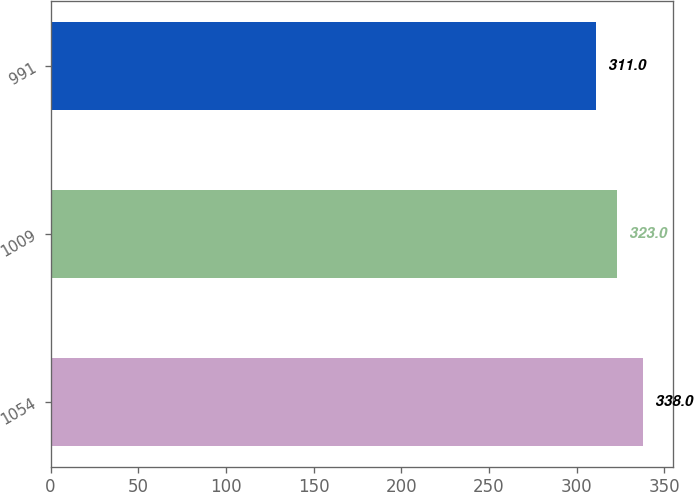Convert chart to OTSL. <chart><loc_0><loc_0><loc_500><loc_500><bar_chart><fcel>1054<fcel>1009<fcel>991<nl><fcel>338<fcel>323<fcel>311<nl></chart> 